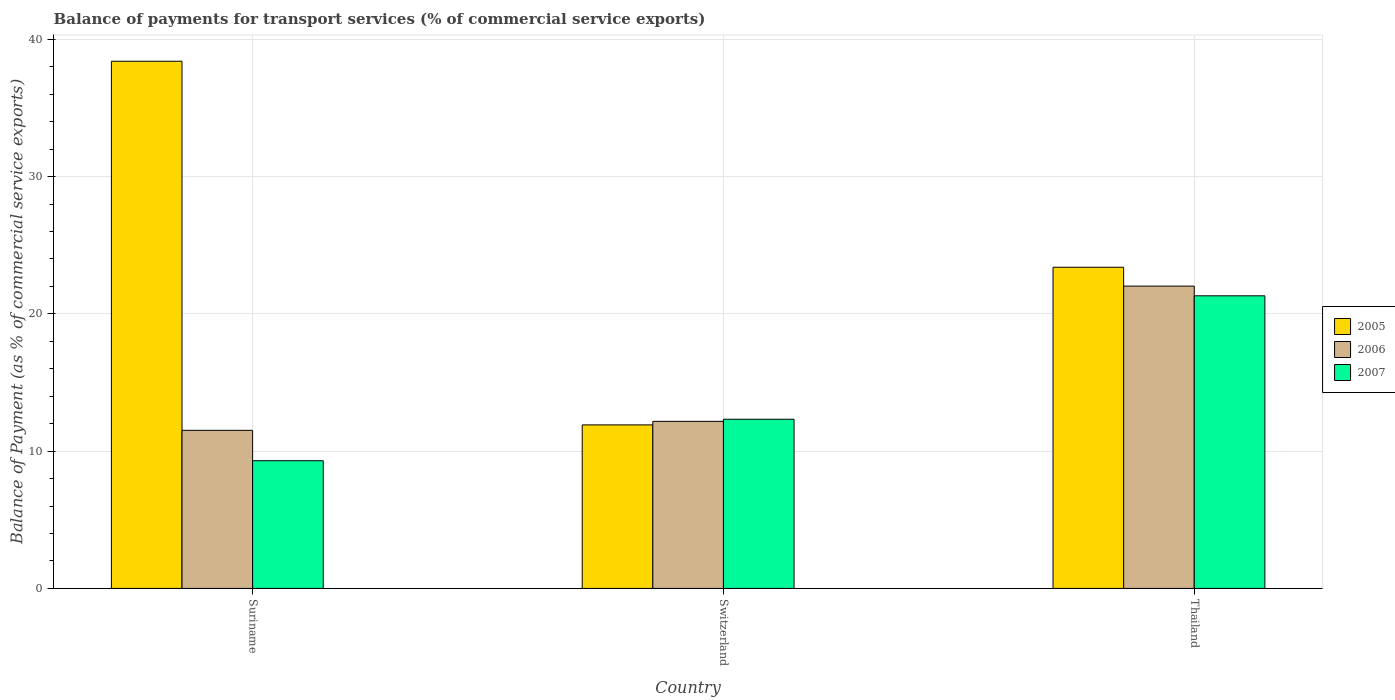How many groups of bars are there?
Keep it short and to the point. 3. Are the number of bars on each tick of the X-axis equal?
Offer a very short reply. Yes. How many bars are there on the 3rd tick from the left?
Your answer should be compact. 3. How many bars are there on the 2nd tick from the right?
Provide a short and direct response. 3. What is the label of the 3rd group of bars from the left?
Provide a short and direct response. Thailand. In how many cases, is the number of bars for a given country not equal to the number of legend labels?
Your answer should be compact. 0. What is the balance of payments for transport services in 2007 in Suriname?
Your answer should be compact. 9.3. Across all countries, what is the maximum balance of payments for transport services in 2005?
Your answer should be compact. 38.41. Across all countries, what is the minimum balance of payments for transport services in 2006?
Provide a short and direct response. 11.52. In which country was the balance of payments for transport services in 2005 maximum?
Make the answer very short. Suriname. In which country was the balance of payments for transport services in 2007 minimum?
Offer a terse response. Suriname. What is the total balance of payments for transport services in 2005 in the graph?
Offer a very short reply. 73.72. What is the difference between the balance of payments for transport services in 2006 in Suriname and that in Switzerland?
Ensure brevity in your answer.  -0.65. What is the difference between the balance of payments for transport services in 2007 in Thailand and the balance of payments for transport services in 2005 in Switzerland?
Provide a succinct answer. 9.4. What is the average balance of payments for transport services in 2005 per country?
Provide a short and direct response. 24.57. What is the difference between the balance of payments for transport services of/in 2005 and balance of payments for transport services of/in 2007 in Switzerland?
Give a very brief answer. -0.41. What is the ratio of the balance of payments for transport services in 2006 in Suriname to that in Thailand?
Make the answer very short. 0.52. What is the difference between the highest and the second highest balance of payments for transport services in 2005?
Your response must be concise. -26.49. What is the difference between the highest and the lowest balance of payments for transport services in 2005?
Give a very brief answer. 26.49. What does the 2nd bar from the left in Switzerland represents?
Offer a very short reply. 2006. Is it the case that in every country, the sum of the balance of payments for transport services in 2006 and balance of payments for transport services in 2005 is greater than the balance of payments for transport services in 2007?
Make the answer very short. Yes. How many bars are there?
Your answer should be very brief. 9. Are all the bars in the graph horizontal?
Provide a short and direct response. No. What is the difference between two consecutive major ticks on the Y-axis?
Give a very brief answer. 10. Are the values on the major ticks of Y-axis written in scientific E-notation?
Make the answer very short. No. How are the legend labels stacked?
Your answer should be very brief. Vertical. What is the title of the graph?
Offer a terse response. Balance of payments for transport services (% of commercial service exports). Does "1990" appear as one of the legend labels in the graph?
Ensure brevity in your answer.  No. What is the label or title of the Y-axis?
Your answer should be very brief. Balance of Payment (as % of commercial service exports). What is the Balance of Payment (as % of commercial service exports) in 2005 in Suriname?
Your answer should be very brief. 38.41. What is the Balance of Payment (as % of commercial service exports) in 2006 in Suriname?
Your answer should be compact. 11.52. What is the Balance of Payment (as % of commercial service exports) in 2007 in Suriname?
Make the answer very short. 9.3. What is the Balance of Payment (as % of commercial service exports) of 2005 in Switzerland?
Offer a terse response. 11.91. What is the Balance of Payment (as % of commercial service exports) in 2006 in Switzerland?
Keep it short and to the point. 12.17. What is the Balance of Payment (as % of commercial service exports) of 2007 in Switzerland?
Give a very brief answer. 12.32. What is the Balance of Payment (as % of commercial service exports) of 2005 in Thailand?
Keep it short and to the point. 23.4. What is the Balance of Payment (as % of commercial service exports) in 2006 in Thailand?
Give a very brief answer. 22.03. What is the Balance of Payment (as % of commercial service exports) of 2007 in Thailand?
Your answer should be very brief. 21.32. Across all countries, what is the maximum Balance of Payment (as % of commercial service exports) of 2005?
Offer a terse response. 38.41. Across all countries, what is the maximum Balance of Payment (as % of commercial service exports) of 2006?
Your answer should be compact. 22.03. Across all countries, what is the maximum Balance of Payment (as % of commercial service exports) of 2007?
Offer a terse response. 21.32. Across all countries, what is the minimum Balance of Payment (as % of commercial service exports) in 2005?
Give a very brief answer. 11.91. Across all countries, what is the minimum Balance of Payment (as % of commercial service exports) of 2006?
Offer a very short reply. 11.52. Across all countries, what is the minimum Balance of Payment (as % of commercial service exports) of 2007?
Your answer should be very brief. 9.3. What is the total Balance of Payment (as % of commercial service exports) in 2005 in the graph?
Your answer should be very brief. 73.72. What is the total Balance of Payment (as % of commercial service exports) of 2006 in the graph?
Provide a succinct answer. 45.71. What is the total Balance of Payment (as % of commercial service exports) of 2007 in the graph?
Your response must be concise. 42.95. What is the difference between the Balance of Payment (as % of commercial service exports) in 2005 in Suriname and that in Switzerland?
Offer a terse response. 26.49. What is the difference between the Balance of Payment (as % of commercial service exports) of 2006 in Suriname and that in Switzerland?
Offer a very short reply. -0.65. What is the difference between the Balance of Payment (as % of commercial service exports) of 2007 in Suriname and that in Switzerland?
Your answer should be very brief. -3.02. What is the difference between the Balance of Payment (as % of commercial service exports) of 2005 in Suriname and that in Thailand?
Give a very brief answer. 15.01. What is the difference between the Balance of Payment (as % of commercial service exports) in 2006 in Suriname and that in Thailand?
Your answer should be very brief. -10.51. What is the difference between the Balance of Payment (as % of commercial service exports) of 2007 in Suriname and that in Thailand?
Keep it short and to the point. -12.01. What is the difference between the Balance of Payment (as % of commercial service exports) in 2005 in Switzerland and that in Thailand?
Your response must be concise. -11.49. What is the difference between the Balance of Payment (as % of commercial service exports) of 2006 in Switzerland and that in Thailand?
Make the answer very short. -9.85. What is the difference between the Balance of Payment (as % of commercial service exports) of 2007 in Switzerland and that in Thailand?
Provide a succinct answer. -8.99. What is the difference between the Balance of Payment (as % of commercial service exports) in 2005 in Suriname and the Balance of Payment (as % of commercial service exports) in 2006 in Switzerland?
Your answer should be very brief. 26.23. What is the difference between the Balance of Payment (as % of commercial service exports) in 2005 in Suriname and the Balance of Payment (as % of commercial service exports) in 2007 in Switzerland?
Your response must be concise. 26.08. What is the difference between the Balance of Payment (as % of commercial service exports) in 2006 in Suriname and the Balance of Payment (as % of commercial service exports) in 2007 in Switzerland?
Your response must be concise. -0.81. What is the difference between the Balance of Payment (as % of commercial service exports) of 2005 in Suriname and the Balance of Payment (as % of commercial service exports) of 2006 in Thailand?
Offer a terse response. 16.38. What is the difference between the Balance of Payment (as % of commercial service exports) in 2005 in Suriname and the Balance of Payment (as % of commercial service exports) in 2007 in Thailand?
Provide a succinct answer. 17.09. What is the difference between the Balance of Payment (as % of commercial service exports) in 2006 in Suriname and the Balance of Payment (as % of commercial service exports) in 2007 in Thailand?
Your answer should be very brief. -9.8. What is the difference between the Balance of Payment (as % of commercial service exports) in 2005 in Switzerland and the Balance of Payment (as % of commercial service exports) in 2006 in Thailand?
Offer a very short reply. -10.11. What is the difference between the Balance of Payment (as % of commercial service exports) in 2005 in Switzerland and the Balance of Payment (as % of commercial service exports) in 2007 in Thailand?
Offer a very short reply. -9.4. What is the difference between the Balance of Payment (as % of commercial service exports) in 2006 in Switzerland and the Balance of Payment (as % of commercial service exports) in 2007 in Thailand?
Give a very brief answer. -9.15. What is the average Balance of Payment (as % of commercial service exports) in 2005 per country?
Your response must be concise. 24.57. What is the average Balance of Payment (as % of commercial service exports) in 2006 per country?
Offer a terse response. 15.24. What is the average Balance of Payment (as % of commercial service exports) of 2007 per country?
Offer a terse response. 14.32. What is the difference between the Balance of Payment (as % of commercial service exports) of 2005 and Balance of Payment (as % of commercial service exports) of 2006 in Suriname?
Provide a succinct answer. 26.89. What is the difference between the Balance of Payment (as % of commercial service exports) of 2005 and Balance of Payment (as % of commercial service exports) of 2007 in Suriname?
Your answer should be compact. 29.1. What is the difference between the Balance of Payment (as % of commercial service exports) of 2006 and Balance of Payment (as % of commercial service exports) of 2007 in Suriname?
Give a very brief answer. 2.21. What is the difference between the Balance of Payment (as % of commercial service exports) of 2005 and Balance of Payment (as % of commercial service exports) of 2006 in Switzerland?
Your answer should be compact. -0.26. What is the difference between the Balance of Payment (as % of commercial service exports) in 2005 and Balance of Payment (as % of commercial service exports) in 2007 in Switzerland?
Give a very brief answer. -0.41. What is the difference between the Balance of Payment (as % of commercial service exports) in 2006 and Balance of Payment (as % of commercial service exports) in 2007 in Switzerland?
Your answer should be compact. -0.15. What is the difference between the Balance of Payment (as % of commercial service exports) in 2005 and Balance of Payment (as % of commercial service exports) in 2006 in Thailand?
Make the answer very short. 1.37. What is the difference between the Balance of Payment (as % of commercial service exports) of 2005 and Balance of Payment (as % of commercial service exports) of 2007 in Thailand?
Provide a short and direct response. 2.08. What is the difference between the Balance of Payment (as % of commercial service exports) in 2006 and Balance of Payment (as % of commercial service exports) in 2007 in Thailand?
Keep it short and to the point. 0.71. What is the ratio of the Balance of Payment (as % of commercial service exports) in 2005 in Suriname to that in Switzerland?
Offer a terse response. 3.22. What is the ratio of the Balance of Payment (as % of commercial service exports) in 2006 in Suriname to that in Switzerland?
Your answer should be compact. 0.95. What is the ratio of the Balance of Payment (as % of commercial service exports) of 2007 in Suriname to that in Switzerland?
Give a very brief answer. 0.76. What is the ratio of the Balance of Payment (as % of commercial service exports) of 2005 in Suriname to that in Thailand?
Offer a very short reply. 1.64. What is the ratio of the Balance of Payment (as % of commercial service exports) in 2006 in Suriname to that in Thailand?
Keep it short and to the point. 0.52. What is the ratio of the Balance of Payment (as % of commercial service exports) in 2007 in Suriname to that in Thailand?
Ensure brevity in your answer.  0.44. What is the ratio of the Balance of Payment (as % of commercial service exports) in 2005 in Switzerland to that in Thailand?
Your answer should be very brief. 0.51. What is the ratio of the Balance of Payment (as % of commercial service exports) in 2006 in Switzerland to that in Thailand?
Give a very brief answer. 0.55. What is the ratio of the Balance of Payment (as % of commercial service exports) in 2007 in Switzerland to that in Thailand?
Make the answer very short. 0.58. What is the difference between the highest and the second highest Balance of Payment (as % of commercial service exports) of 2005?
Make the answer very short. 15.01. What is the difference between the highest and the second highest Balance of Payment (as % of commercial service exports) in 2006?
Provide a short and direct response. 9.85. What is the difference between the highest and the second highest Balance of Payment (as % of commercial service exports) in 2007?
Keep it short and to the point. 8.99. What is the difference between the highest and the lowest Balance of Payment (as % of commercial service exports) in 2005?
Provide a short and direct response. 26.49. What is the difference between the highest and the lowest Balance of Payment (as % of commercial service exports) of 2006?
Ensure brevity in your answer.  10.51. What is the difference between the highest and the lowest Balance of Payment (as % of commercial service exports) in 2007?
Provide a succinct answer. 12.01. 